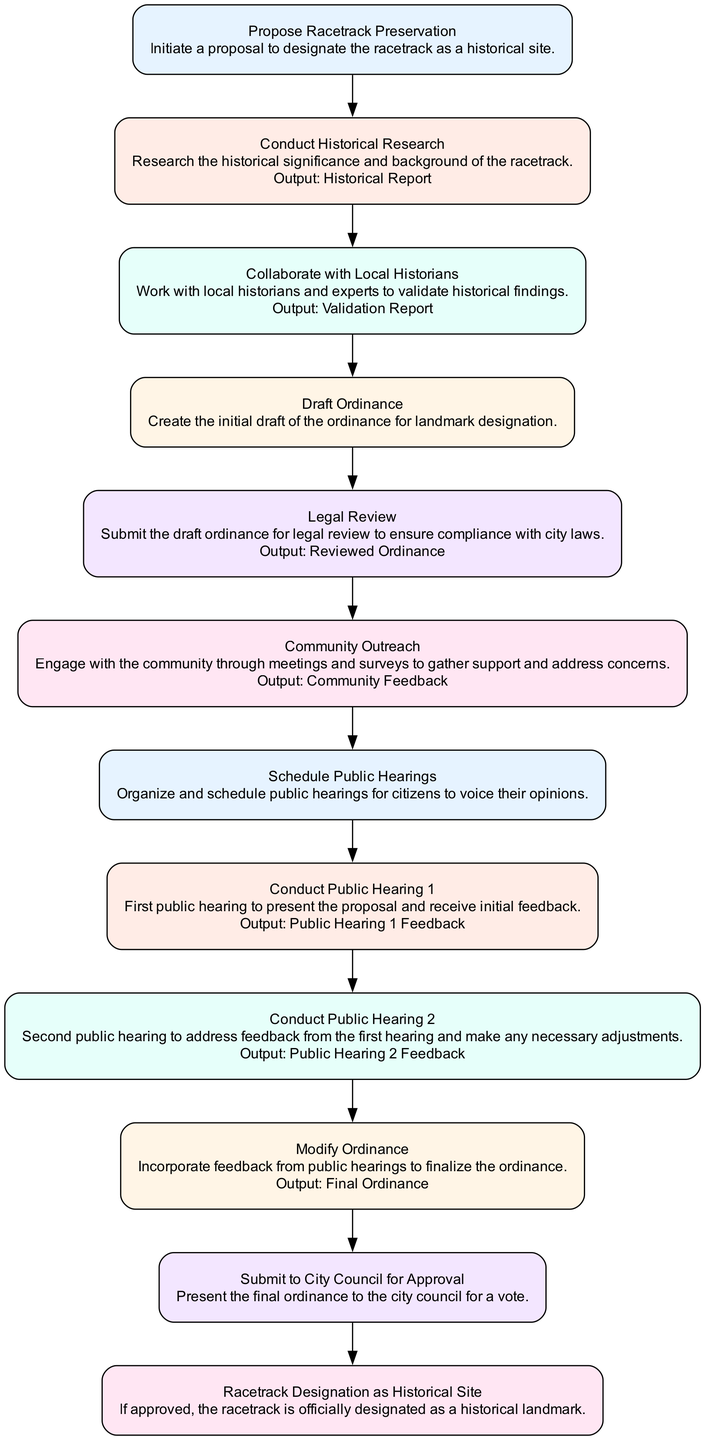What is the first action in the diagram? The first action listed in the diagram is "Propose Racetrack Preservation" under the "initiate" node. This indicates the initial step in the process of designating the racetrack as a historical site.
Answer: Propose Racetrack Preservation How many outputs are specified in the diagram? The diagram specifies outputs for three actions: "Historical Report," "Validation Report," and "Community Feedback." This counts to a total of three distinct outputs.
Answer: Three What action follows "Community Outreach"? According to the flowchart, after the "Community Outreach" action, the next action that follows is "Schedule Public Hearings." This indicates a sequential action from engaging the community to organizing public hearings.
Answer: Schedule Public Hearings Which actions involve public hearings? The actions that involve public hearings are "Conduct Public Hearing 1" and "Conduct Public Hearing 2". These are two steps in which public opinions and feedback are gathered.
Answer: Conduct Public Hearing 1 and Conduct Public Hearing 2 What is the final action in the flowchart? The final action in the flowchart is "Racetrack Designation as Historical Site," indicating the completion of the designation process if the ordinance is approved.
Answer: Racetrack Designation as Historical Site How does "Collaborate with Local Historians" relate to "Conduct Public Hearing 1"? "Collaborate with Local Historians" is a preceding action that contributes to the foundational understanding of the racetrack's historical significance, which is important for presenting information during "Conduct Public Hearing 1." Hence, it helps build context for the public's feedback later.
Answer: Preceding context for feedback What happens after "Modify Ordinance"? Following "Modify Ordinance," the next action is "Submit to City Council for Approval." This means that after incorporating feedback, the ordinance goes to the city council for a formal vote.
Answer: Submit to City Council for Approval Which action is directly connected to "Legal Review"? The action that is directly connected to "Legal Review" is "Community Outreach." After legal checks, engaging with the community is the next step in the legal process.
Answer: Community Outreach What is the relationship between "Research" and the output produced? "Research" involves conducting historical research, which produces the "Historical Report" as an output. This report provides necessary documentation of the racetrack's significance, crucial for the next steps in the approval process.
Answer: Produces Historical Report 